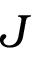Convert formula to latex. <formula><loc_0><loc_0><loc_500><loc_500>J</formula> 